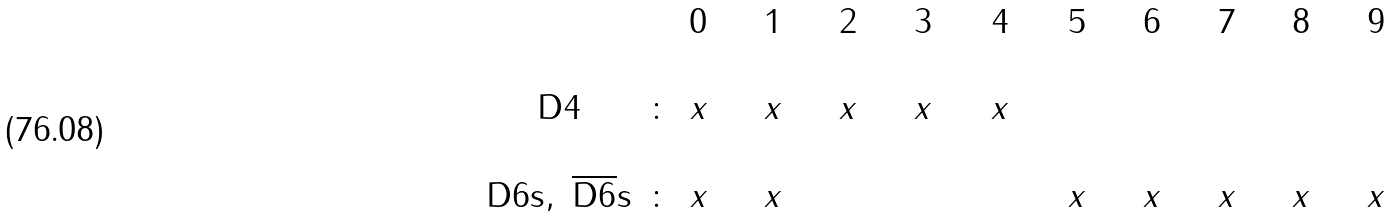<formula> <loc_0><loc_0><loc_500><loc_500>\begin{array} { c c c c c c c c c c c c c c c c c c c c c c c c c c c c c c c c c c c c c c c c } & & 0 & \ \ & 1 & \ \ & 2 & \ \ & 3 & \ \ & 4 & \ \ & 5 & \ \ & 6 & \ \ & 7 & \ \ & 8 & \ \ & 9 & \\ \\ \text {D} 4 & \colon & x & \ \ & x & \ \ & x & \ \ & x & \ \ & x & \\ \\ \text {D} 6 \text {s} , \ { \overline { \text {D} 6 } \text {s} } & \colon & x & \ \ & x & \ \ & \ & \ \ & \ & \ \ & \ \ & \ \ & x & \ \ & x & \ \ & x & \ \ & x & \ \ & x & \\ \\ \end{array}</formula> 